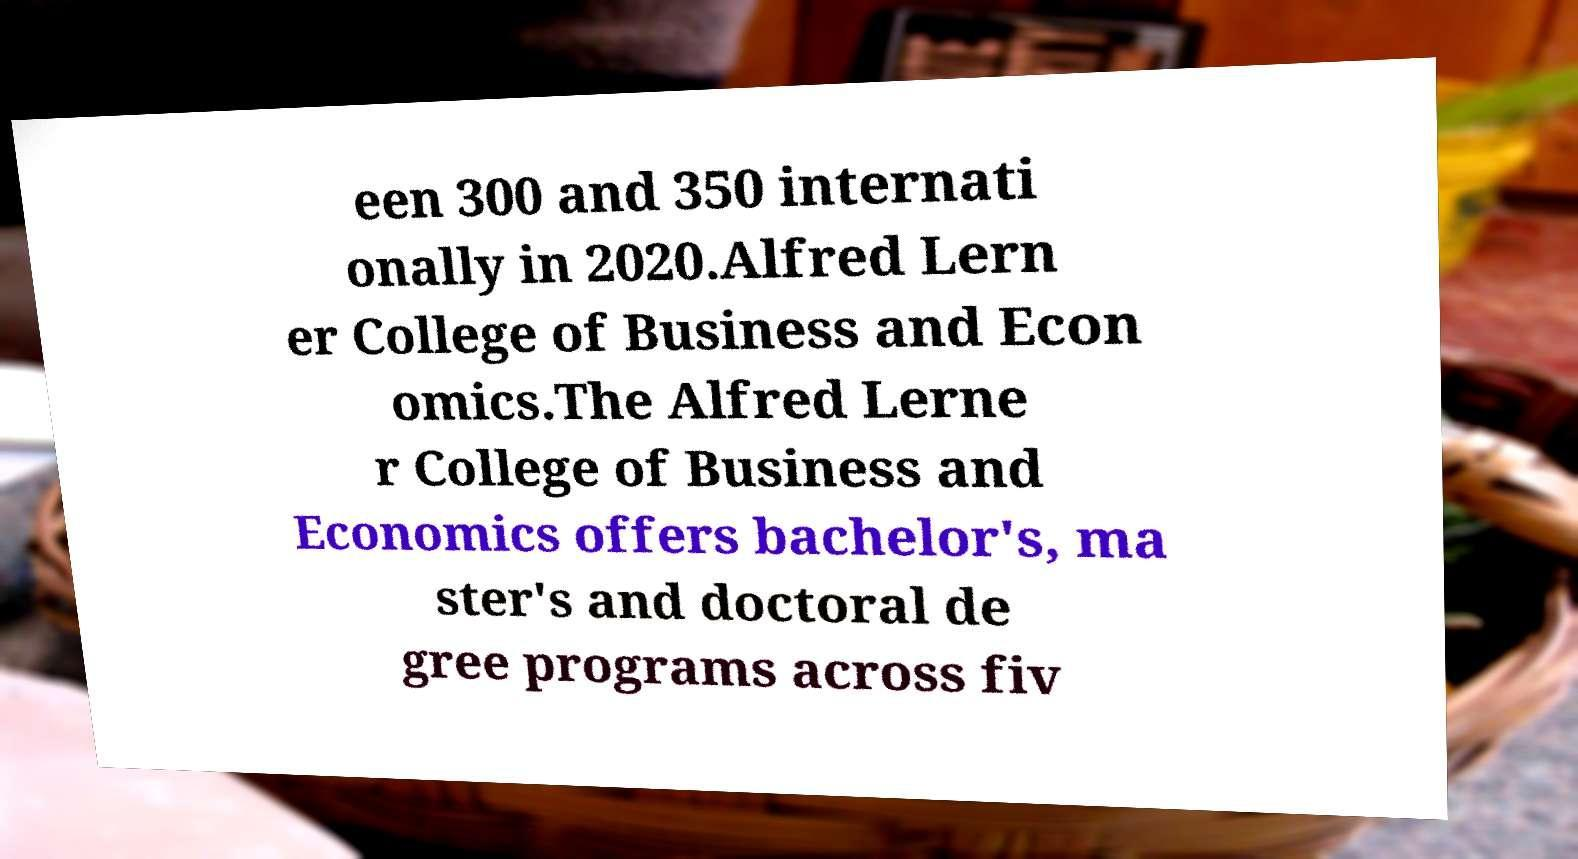Please identify and transcribe the text found in this image. een 300 and 350 internati onally in 2020.Alfred Lern er College of Business and Econ omics.The Alfred Lerne r College of Business and Economics offers bachelor's, ma ster's and doctoral de gree programs across fiv 